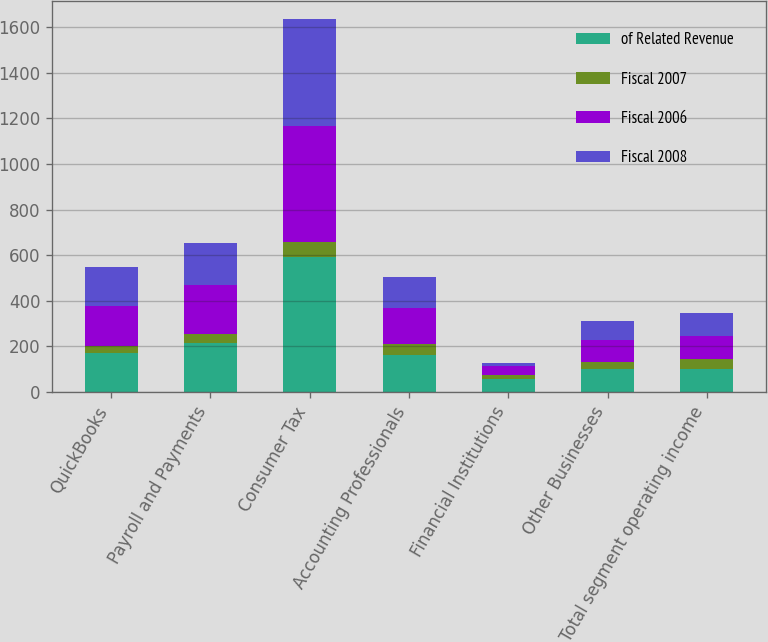Convert chart. <chart><loc_0><loc_0><loc_500><loc_500><stacked_bar_chart><ecel><fcel>QuickBooks<fcel>Payroll and Payments<fcel>Consumer Tax<fcel>Accounting Professionals<fcel>Financial Institutions<fcel>Other Businesses<fcel>Total segment operating income<nl><fcel>of Related Revenue<fcel>172.3<fcel>216.3<fcel>594.5<fcel>162.6<fcel>57<fcel>101<fcel>101<nl><fcel>Fiscal 2007<fcel>28<fcel>39<fcel>64<fcel>50<fcel>19<fcel>30<fcel>42<nl><fcel>Fiscal 2006<fcel>178.8<fcel>215.4<fcel>508.6<fcel>154.4<fcel>38.8<fcel>98.7<fcel>101<nl><fcel>Fiscal 2008<fcel>167.4<fcel>181.9<fcel>467.1<fcel>136.7<fcel>12.2<fcel>83.8<fcel>101<nl></chart> 